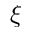Convert formula to latex. <formula><loc_0><loc_0><loc_500><loc_500>\xi</formula> 